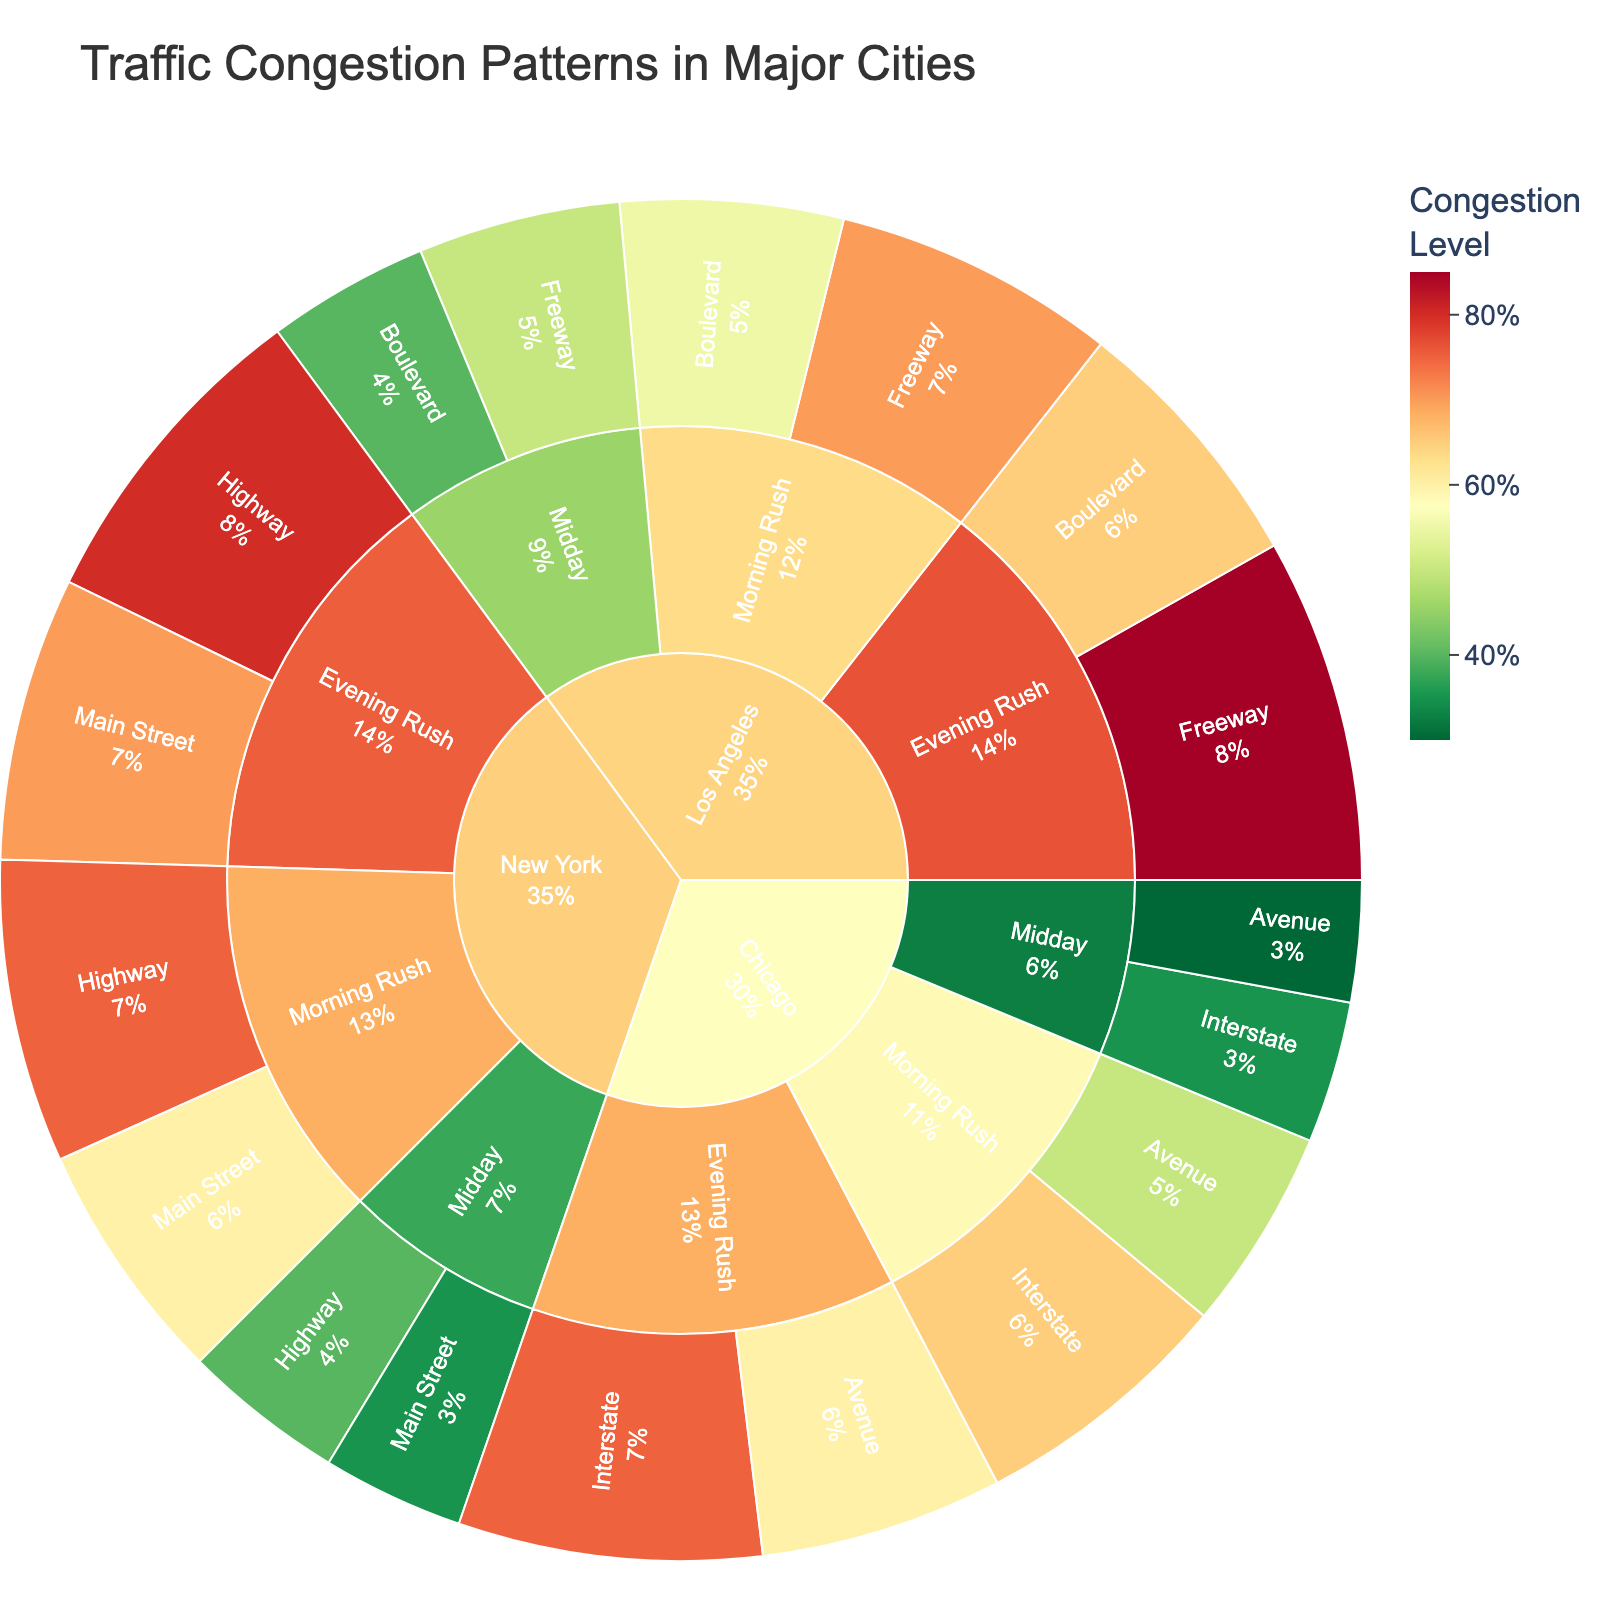what is the title of the sunburst plot? The title is displayed prominently at the top of the figure. Simply read the title from that position.
Answer: Traffic Congestion Patterns in Major Cities Which city has the highest congestion level during the Evening Rush on highways? Locate the city segments on the sunburst plot, then identify the "Evening Rush" segments within each city. From there, compare the congestion levels for highways.
Answer: Los Angeles What is the congestion level on main streets in New York during the Morning Rush? Focus on the New York segment, then drill down to the "Morning Rush" and within that, find the main streets segment to read the congestion level.
Answer: 60% Comparing Los Angeles and Chicago, which city has a lower congestion level on the freeway/interstate during midday? First, locate the midday segments under Los Angeles and Chicago. Then compare the congestion levels of the freeway in Los Angeles and the interstate in Chicago.
Answer: Chicago What is the combined congestion level for highways and main streets in New York during Evening Rush? Find the New York segment, then go to Evening Rush and sum the congestion levels for both highways and main streets. Calculate: 80 + 70 = 150
Answer: 150% Which road type has the highest congestion level in Chicago during Morning Rush? Focus on the Chicago segment, then find the Morning Rush segment and compare the congestion levels for interstate and avenue.
Answer: Interstate Among the three cities, which city has the highest congestion level during the Midday on main streets/avenues? Locate the Midday segments for each city, then compare the congestion levels for main streets in New York, boulevards in Los Angeles, and avenues in Chicago.
Answer: New York What is the congestion level in Los Angeles during Evening Rush in boulevards? Focus on Los Angeles, then look at the Evening Rush segment, and find the boulevard segment for the congestion level.
Answer: 65% Which time of day has the lowest overall congestion in Chicago? Compare the congestion levels for Morning Rush, Midday, and Evening Rush segments under the Chicago segment. Focus on summing up levels for respective road types if necessary: (65 + 50) for Morning Rush, (35 + 30) for Midday, and (75 + 60) for Evening Rush.
Answer: Midday 